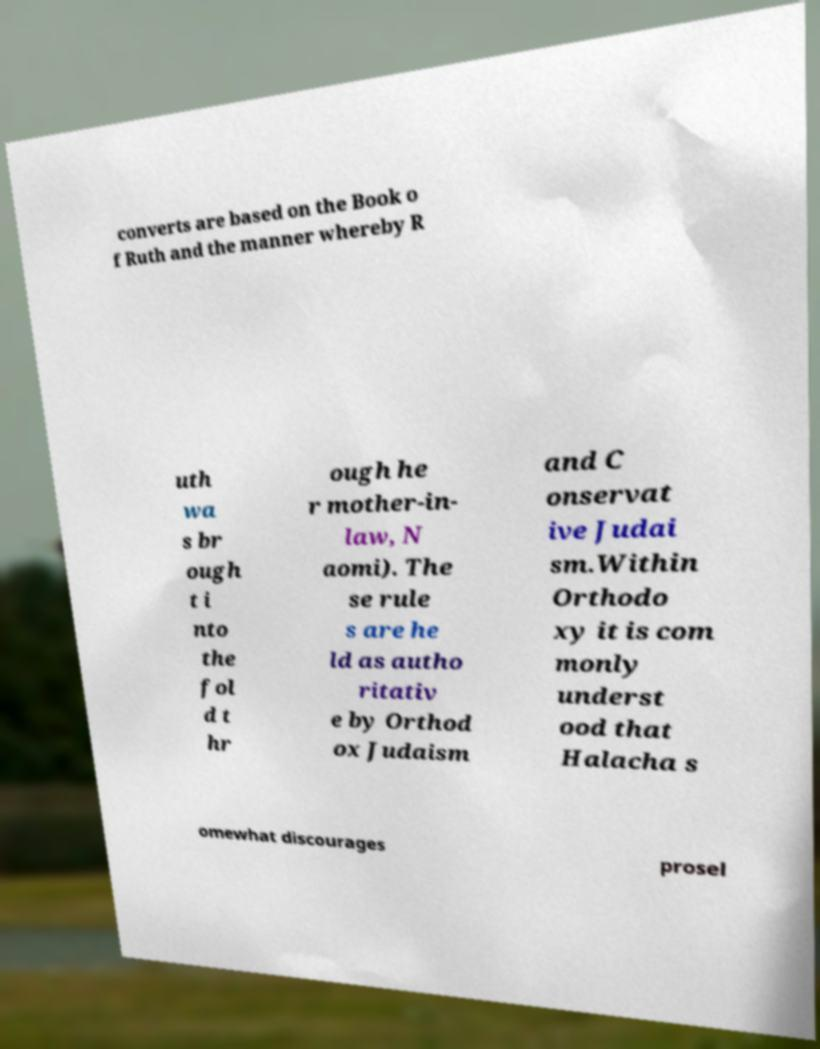Could you extract and type out the text from this image? converts are based on the Book o f Ruth and the manner whereby R uth wa s br ough t i nto the fol d t hr ough he r mother-in- law, N aomi). The se rule s are he ld as autho ritativ e by Orthod ox Judaism and C onservat ive Judai sm.Within Orthodo xy it is com monly underst ood that Halacha s omewhat discourages prosel 